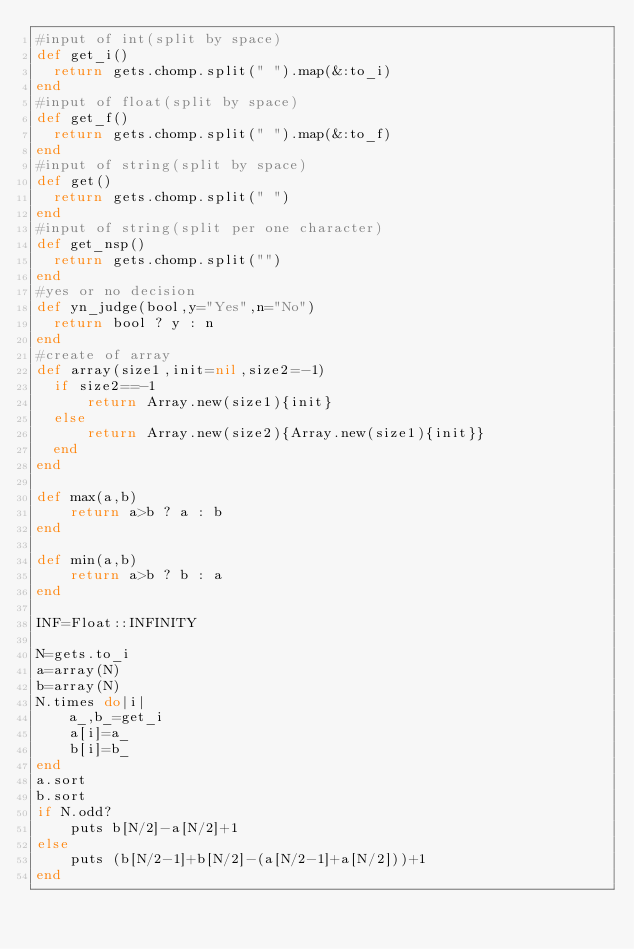Convert code to text. <code><loc_0><loc_0><loc_500><loc_500><_Ruby_>#input of int(split by space)
def get_i()
  return gets.chomp.split(" ").map(&:to_i)
end
#input of float(split by space)
def get_f()
  return gets.chomp.split(" ").map(&:to_f)
end
#input of string(split by space)
def get()
  return gets.chomp.split(" ")
end
#input of string(split per one character)
def get_nsp()
  return gets.chomp.split("")
end
#yes or no decision
def yn_judge(bool,y="Yes",n="No")
  return bool ? y : n 
end
#create of array
def array(size1,init=nil,size2=-1)
  if size2==-1
      return Array.new(size1){init}
  else
      return Array.new(size2){Array.new(size1){init}}
  end
end

def max(a,b)
    return a>b ? a : b
end

def min(a,b)
    return a>b ? b : a
end

INF=Float::INFINITY

N=gets.to_i
a=array(N)
b=array(N)
N.times do|i|
    a_,b_=get_i
    a[i]=a_
    b[i]=b_
end
a.sort
b.sort
if N.odd?
    puts b[N/2]-a[N/2]+1
else
    puts (b[N/2-1]+b[N/2]-(a[N/2-1]+a[N/2]))+1
end</code> 